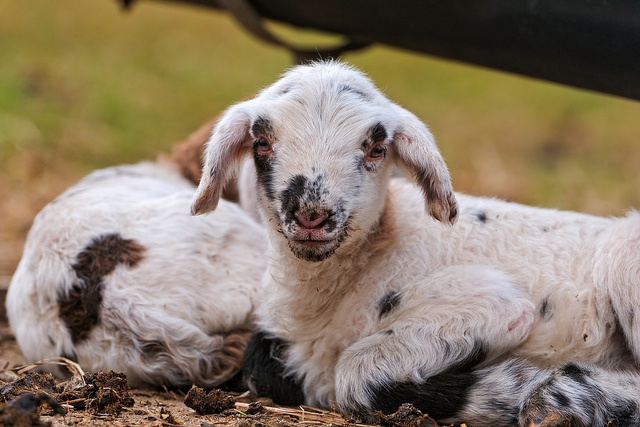Describe the objects in this image and their specific colors. I can see sheep in olive, darkgray, lightgray, gray, and black tones and sheep in olive, lightgray, darkgray, and black tones in this image. 